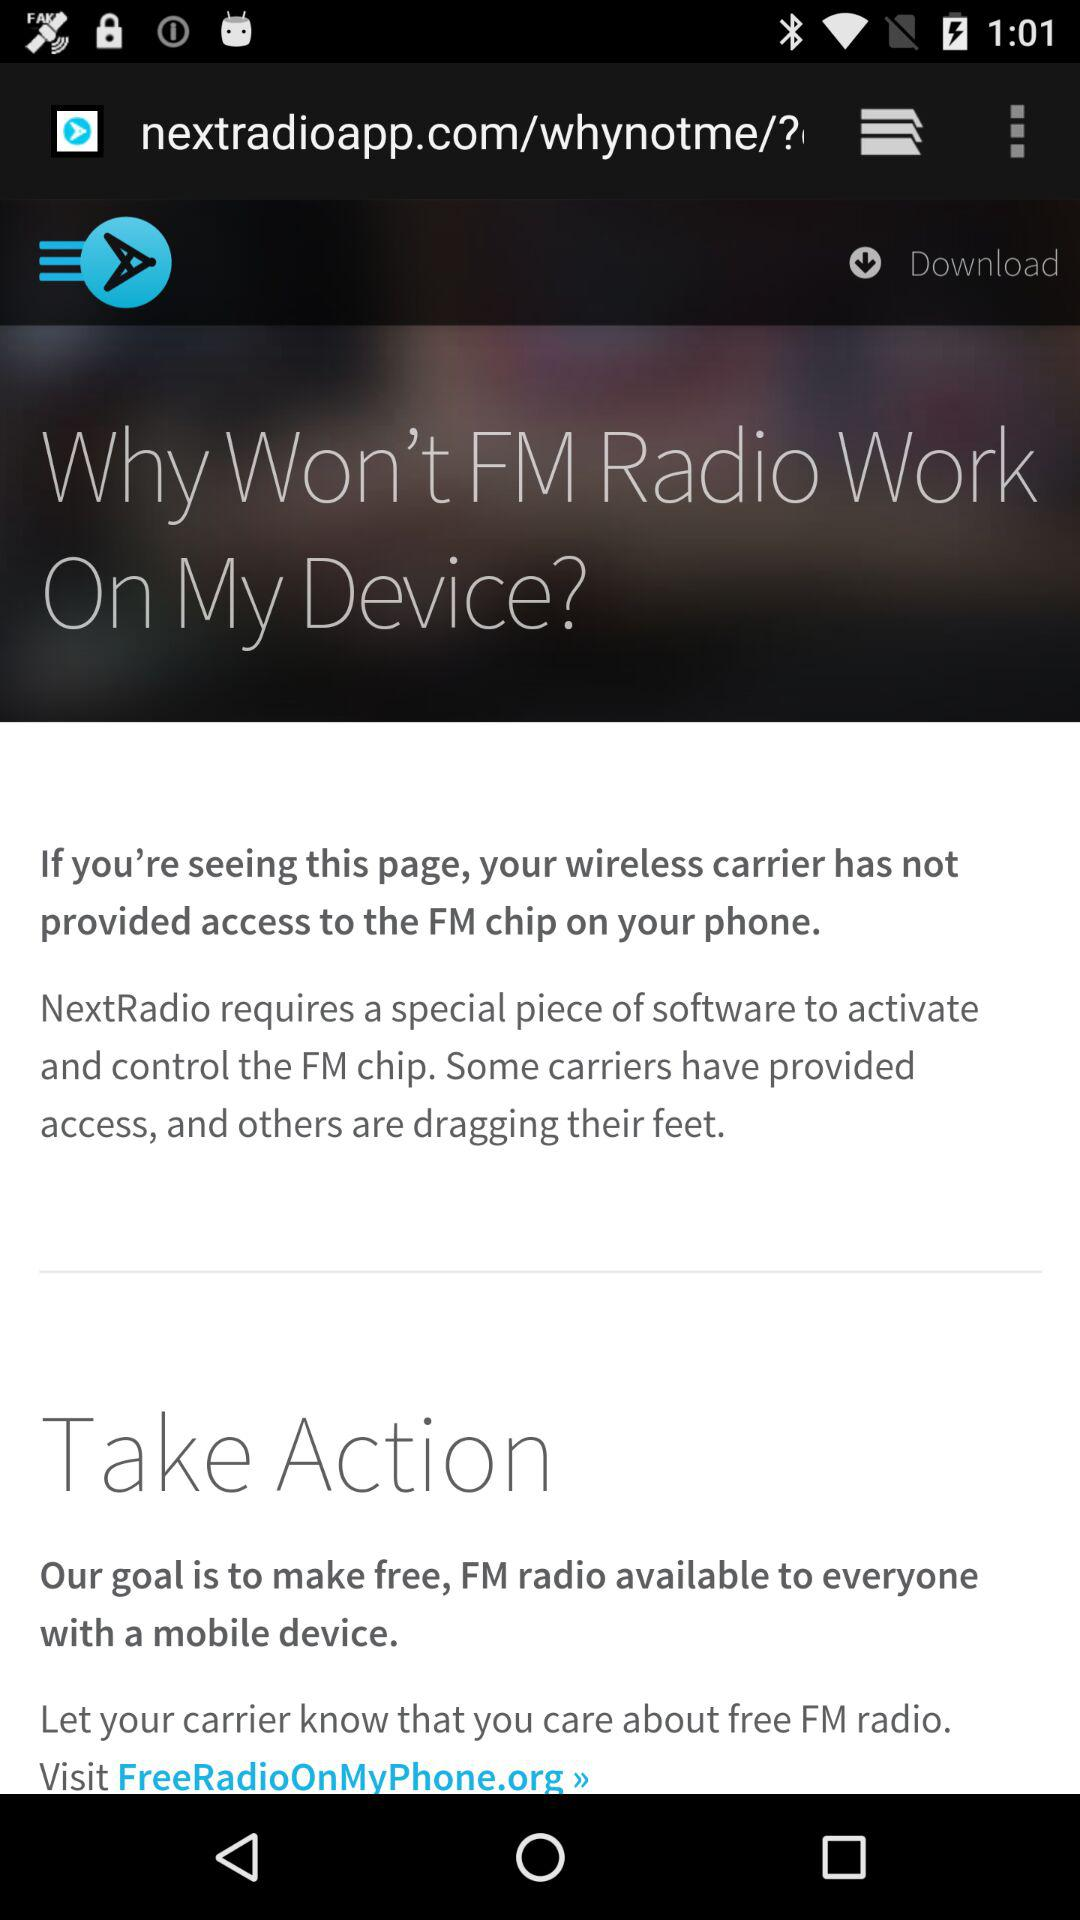Which website can be visited to let the carrier know that I care about free FM radio? The website is FreeRadioOnMyPhone.org. 